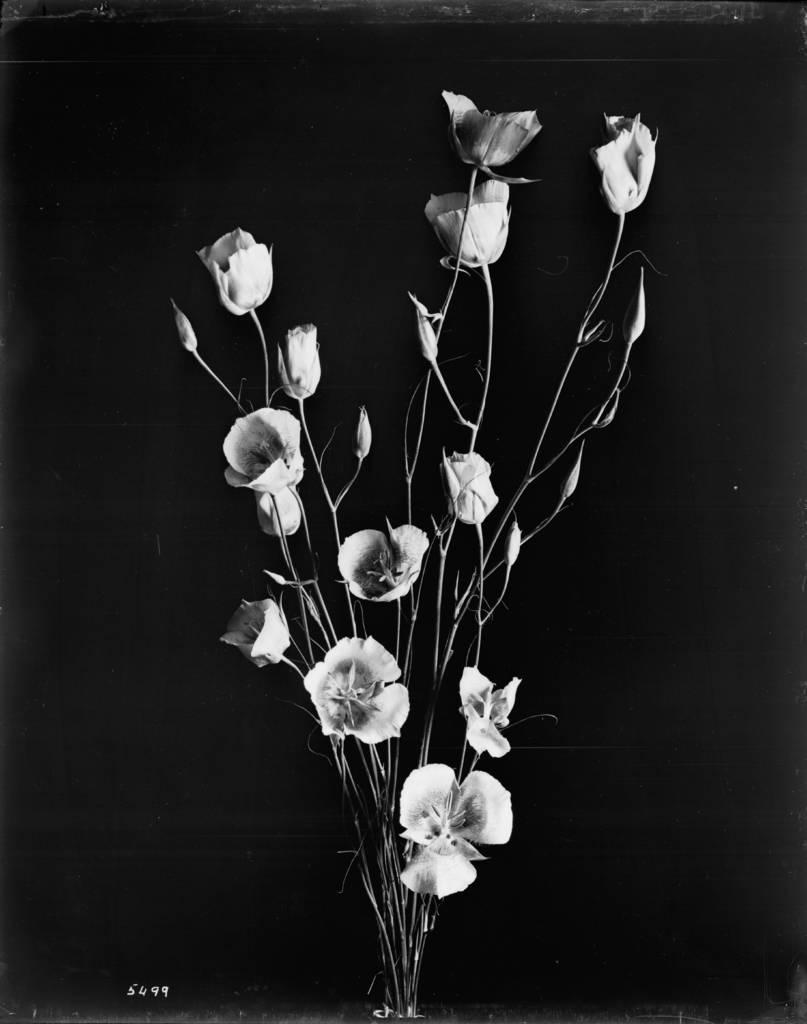Can you describe this image briefly? It is a black and white picture. Here we can see plants, stems, leaves and flower buds. At the bottom of the image, we can see numbers. Background it is dark view. 